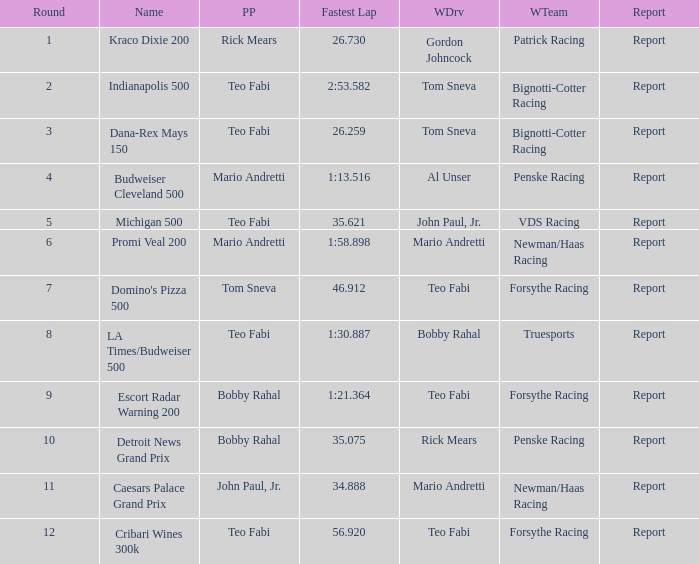What was the fastest lap time in the Escort Radar Warning 200? 1:21.364. 